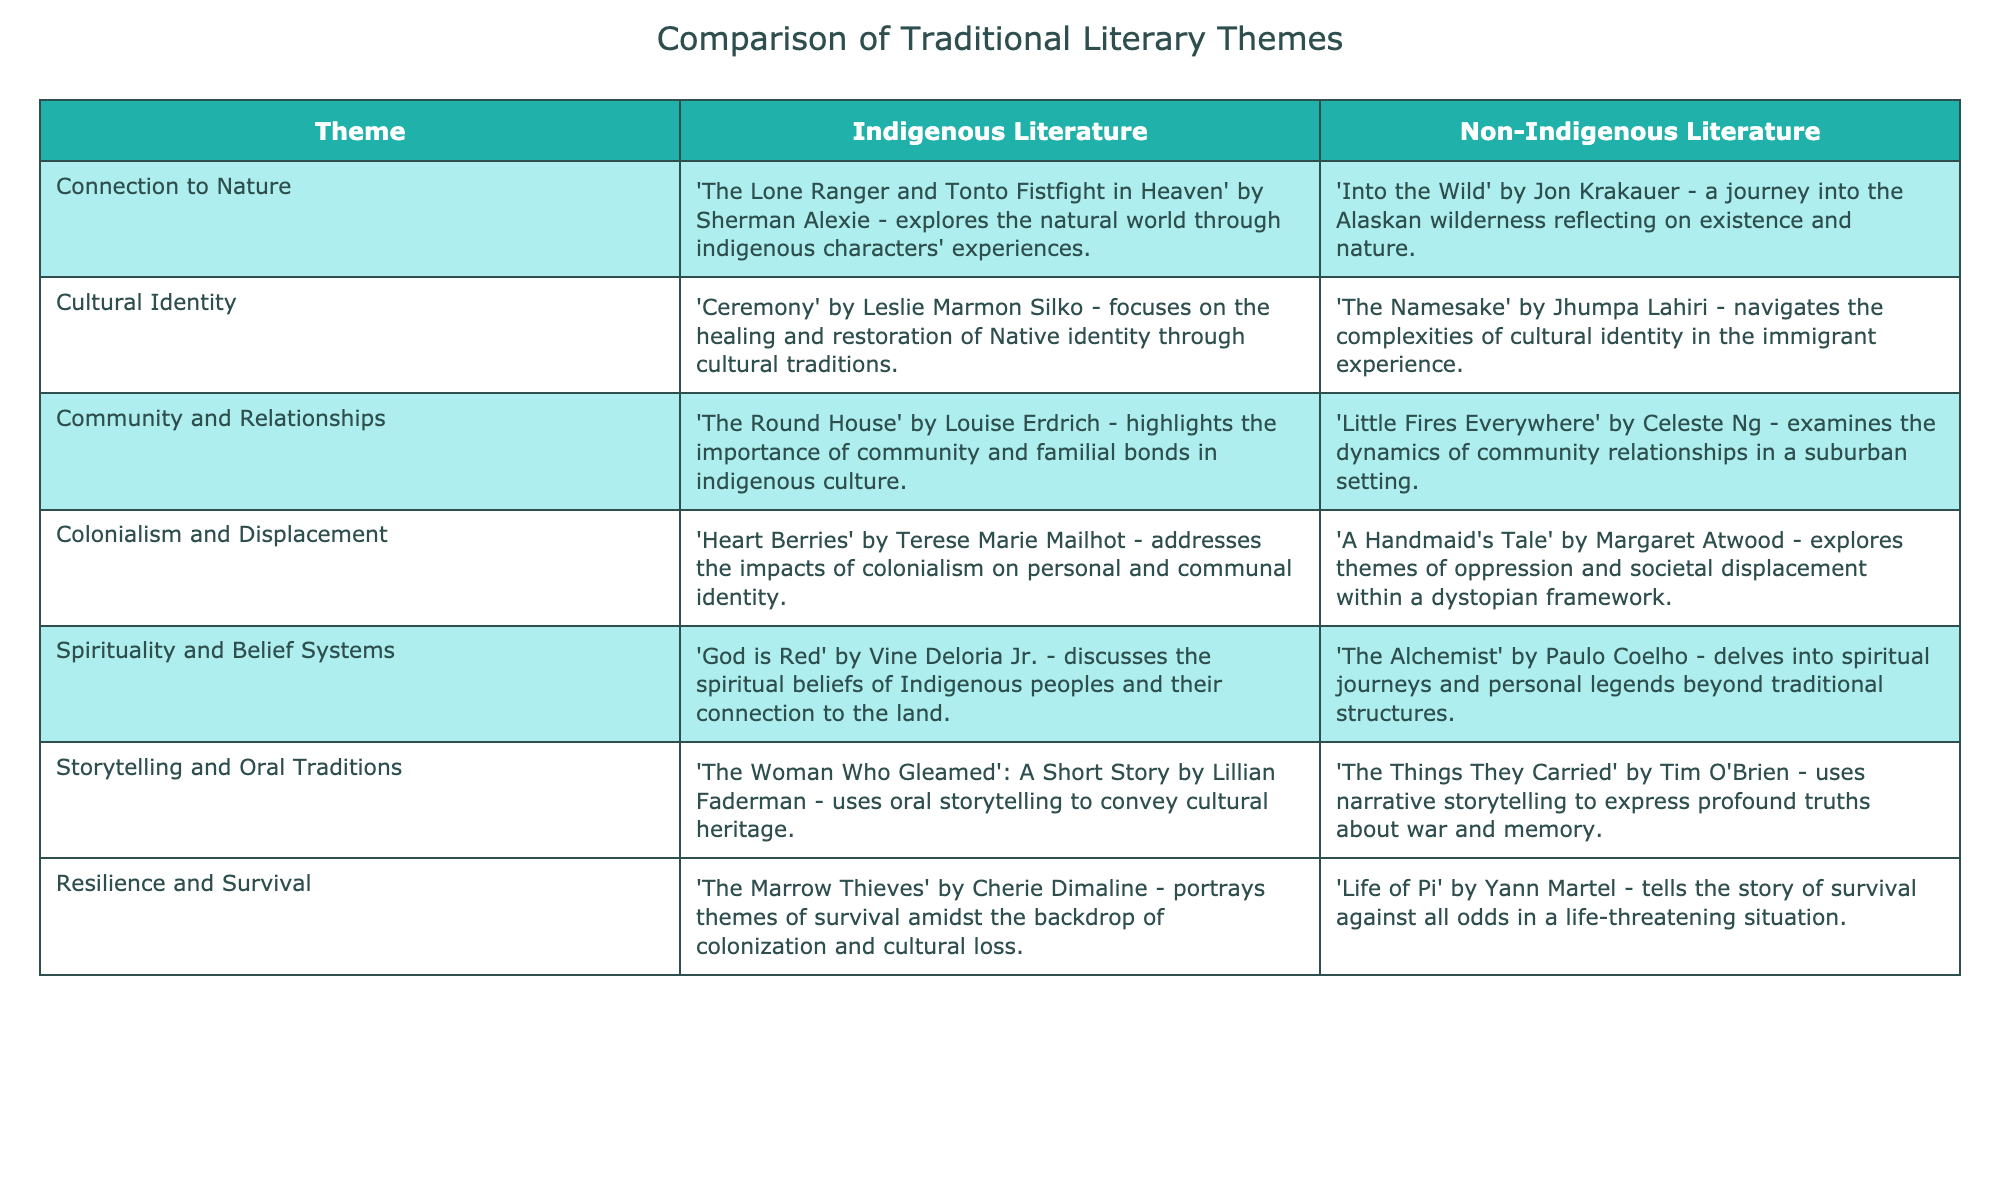What is the Indigenous literature that addresses the impacts of colonialism? The table specifies that the Indigenous literature addressing colonialism is "Heart Berries" by Terese Marie Mailhot. This can be found by looking in the "Colonialism and Displacement" row under "Indigenous Literature."
Answer: Heart Berries Which non-Indigenous literary work explores themes of cultural identity? According to the table, "The Namesake" by Jhumpa Lahiri explores themes of cultural identity under the "Cultural Identity" row in the "Non-Indigenous Literature" column.
Answer: The Namesake Is "Life of Pi" by Yann Martel associated with the theme of resilience and survival? Yes, the table clearly shows "Life of Pi" is listed under the "Resilience and Survival" row in the "Non-Indigenous Literature" column, confirming its connection to that theme.
Answer: Yes Which work discusses spiritual journeys in a non-traditional context? The table indicates that "The Alchemist" by Paulo Coelho delves into spiritual journeys beyond traditional structures, found in the "Spirituality and Belief Systems" row under the non-Indigenous literature.
Answer: The Alchemist How many literary themes are associated with works by Indigenous authors, according to the table? The table lists a total of seven themes. Each theme corresponds to an indigenous work, indicating that there are seven literary themes associated with Indigenous authors' writings.
Answer: Seven What is the difference between the focus of storytelling in Indigenous literature compared to non-Indigenous literature? The table states that Indigenous literature often uses oral storytelling to convey cultural heritage, as seen in "The Woman Who Gleamed." In contrast, non-Indigenous literature, such as "The Things They Carried," uses narrative storytelling that expresses profound truths about war. This reflects a difference in cultural context and approaches to storytelling.
Answer: Oral vs. narrative storytelling Are community dynamics explored in both Indigenous and non-Indigenous literature? Yes, the table shows that both Indigenous literature ("The Round House" by Louise Erdrich) and non-Indigenous literature ("Little Fires Everywhere" by Celeste Ng) examine community dynamics, indicating this theme is present in both literary traditions.
Answer: Yes Which themes are common between "The Round House" and "Little Fires Everywhere"? Both works explore themes of community and relationships, as indicated in the respective rows for each title. "The Round House" focuses on community and familial bonds in indigenous culture, while "Little Fires Everywhere" examines dynamics in suburban communities. Thus, the common theme is community relationships.
Answer: Community and relationships What is the relationship between "Connection to Nature" in Indigenous literature and "Into the Wild"? The table presents "Connection to Nature" as a theme in Indigenous literature through the work of Sherman Alexie, and similarly in non-Indigenous literature through Jon Krakauer's "Into the Wild." Both works explore experiences in nature but reflect differing cultural perspectives, highlighting the diversity in how nature is represented in their respective contexts.
Answer: Cultural perspective in nature 